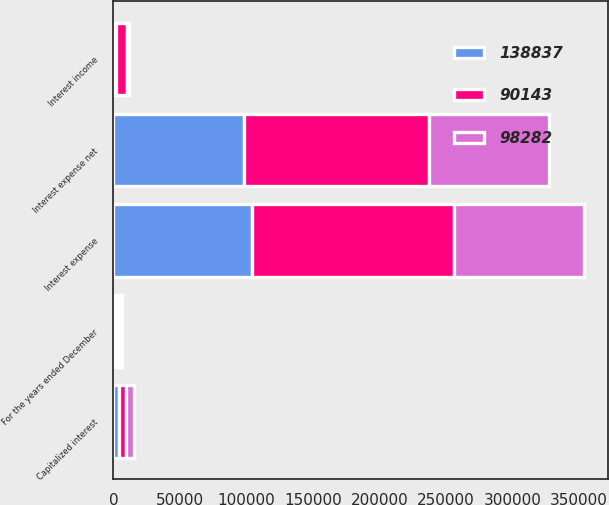<chart> <loc_0><loc_0><loc_500><loc_500><stacked_bar_chart><ecel><fcel>For the years ended December<fcel>Interest expense<fcel>Capitalized interest<fcel>Interest income<fcel>Interest expense net<nl><fcel>90143<fcel>2018<fcel>151950<fcel>5092<fcel>8021<fcel>138837<nl><fcel>138837<fcel>2017<fcel>104232<fcel>4166<fcel>1784<fcel>98282<nl><fcel>98282<fcel>2016<fcel>97851<fcel>5903<fcel>1805<fcel>90143<nl></chart> 